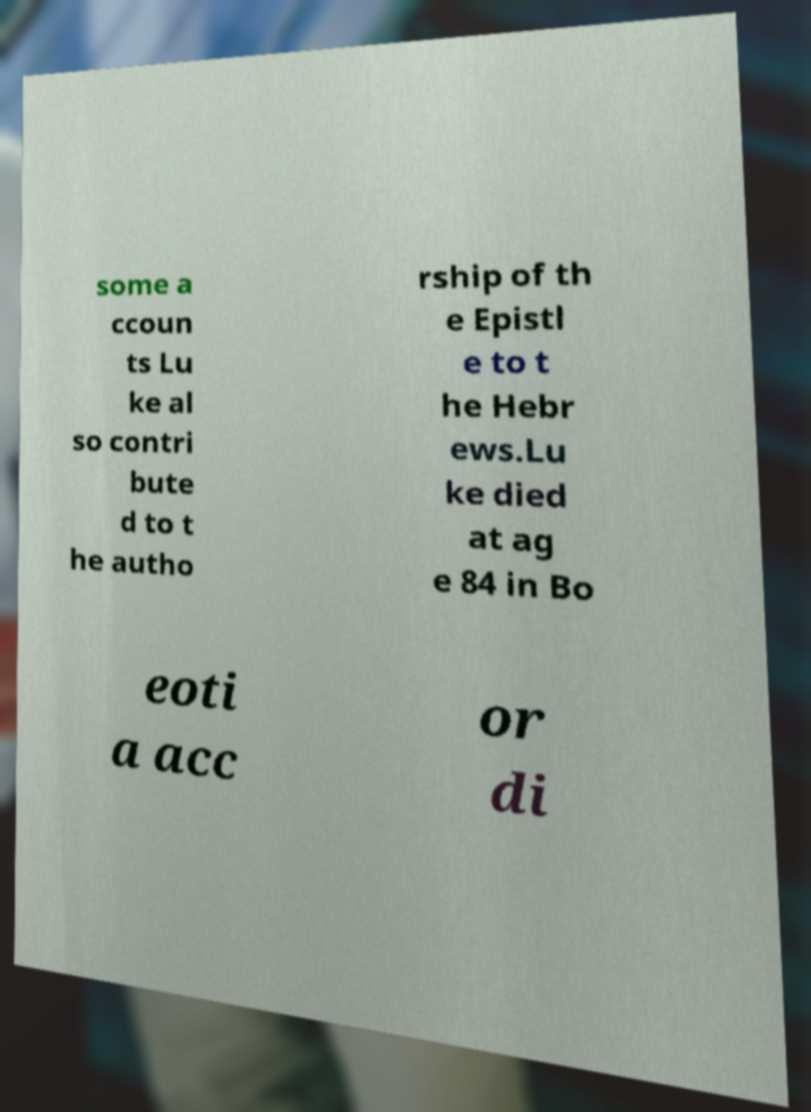Please identify and transcribe the text found in this image. some a ccoun ts Lu ke al so contri bute d to t he autho rship of th e Epistl e to t he Hebr ews.Lu ke died at ag e 84 in Bo eoti a acc or di 